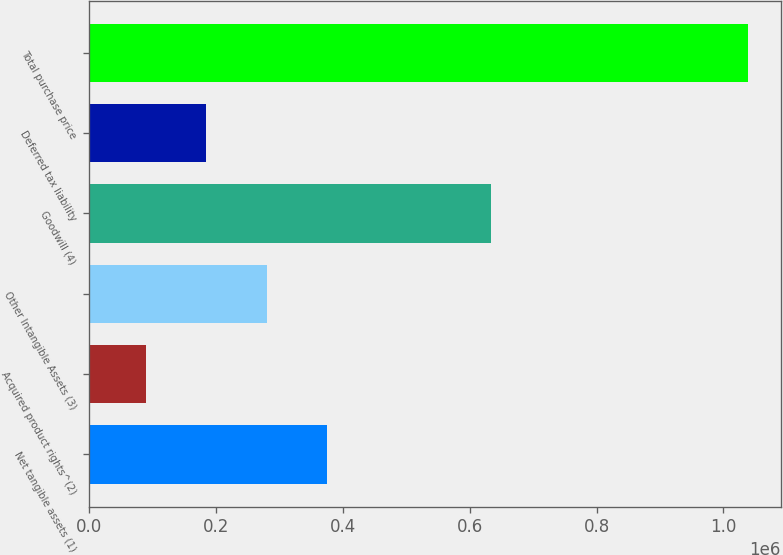<chart> <loc_0><loc_0><loc_500><loc_500><bar_chart><fcel>Net tangible assets (1)<fcel>Acquired product rights^(2)<fcel>Other Intangible Assets (3)<fcel>Goodwill (4)<fcel>Deferred tax liability<fcel>Total purchase price<nl><fcel>374415<fcel>89920<fcel>279584<fcel>633233<fcel>184752<fcel>1.03824e+06<nl></chart> 